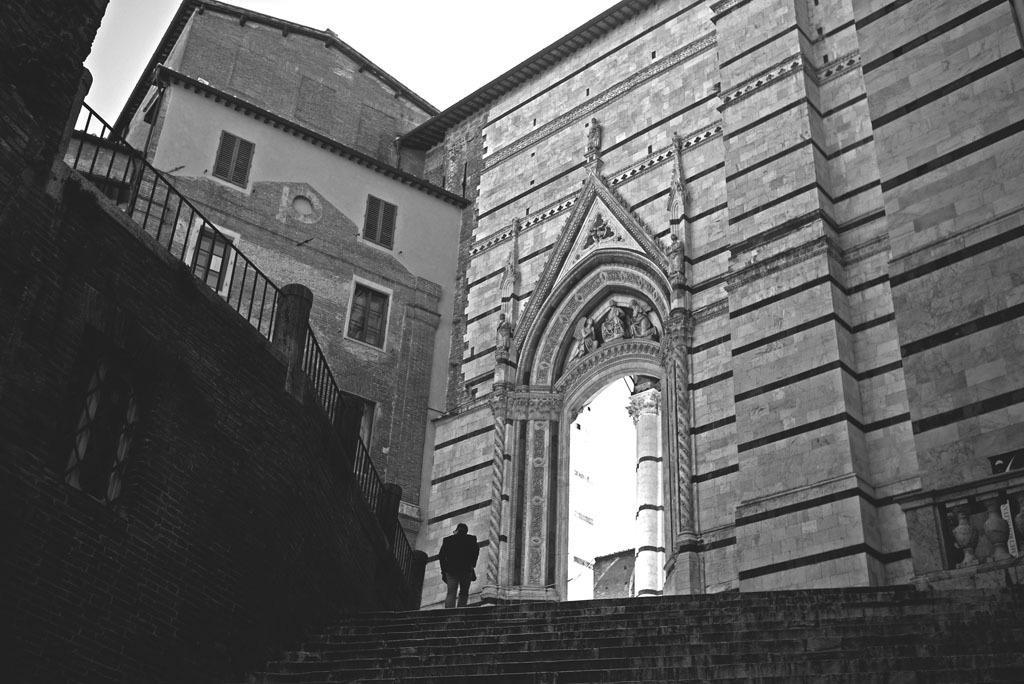Describe this image in one or two sentences. In this picture the man standing on the stairs and there is a building and the sky is cloudy. 